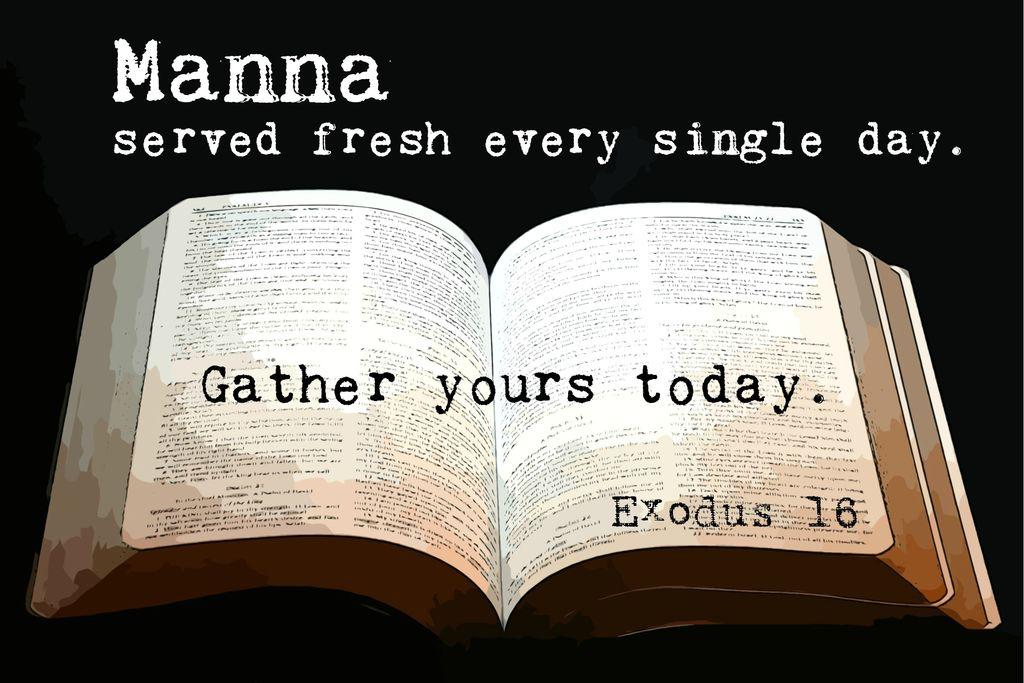<image>
Give a short and clear explanation of the subsequent image. Over a open book, the words Exodus 16 appear. 